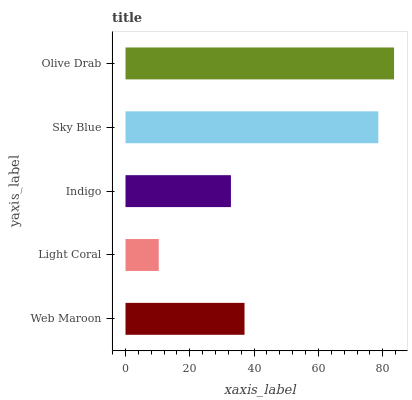Is Light Coral the minimum?
Answer yes or no. Yes. Is Olive Drab the maximum?
Answer yes or no. Yes. Is Indigo the minimum?
Answer yes or no. No. Is Indigo the maximum?
Answer yes or no. No. Is Indigo greater than Light Coral?
Answer yes or no. Yes. Is Light Coral less than Indigo?
Answer yes or no. Yes. Is Light Coral greater than Indigo?
Answer yes or no. No. Is Indigo less than Light Coral?
Answer yes or no. No. Is Web Maroon the high median?
Answer yes or no. Yes. Is Web Maroon the low median?
Answer yes or no. Yes. Is Indigo the high median?
Answer yes or no. No. Is Indigo the low median?
Answer yes or no. No. 